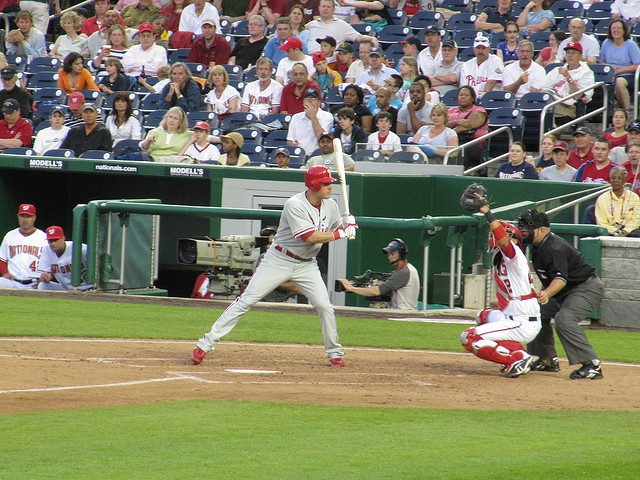Describe the objects in this image and their specific colors. I can see people in maroon, lightgray, gray, and black tones, chair in maroon, gray, darkblue, black, and lightgray tones, people in maroon, lightgray, darkgray, gray, and brown tones, people in maroon, black, gray, darkgreen, and tan tones, and people in maroon, white, brown, and darkgray tones in this image. 